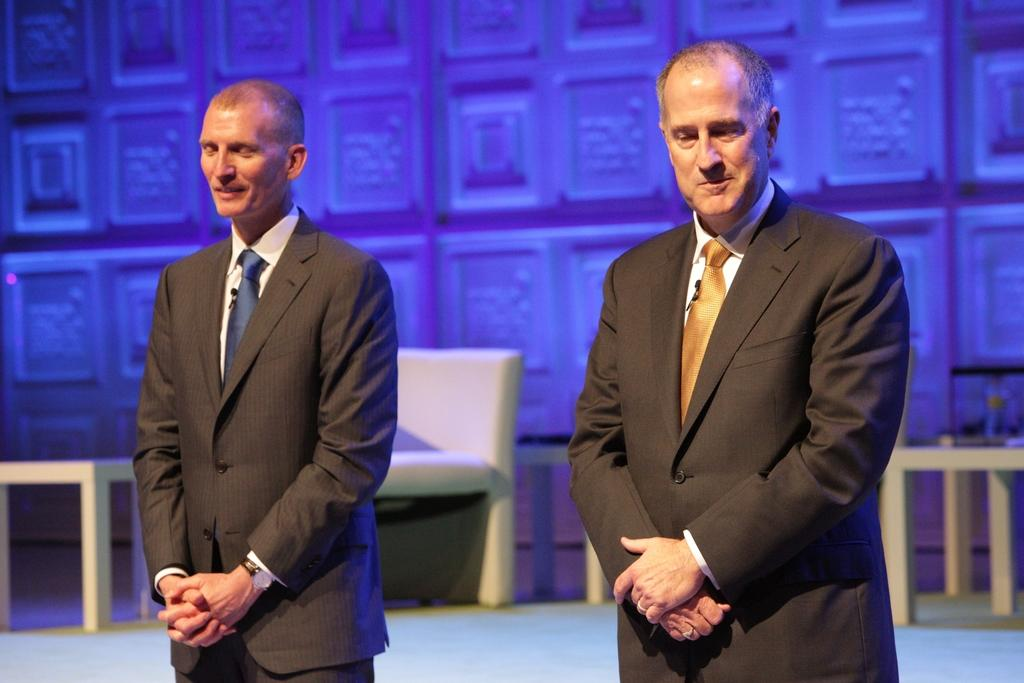What is happening in the image? There are people standing in the image. What can be seen in the background of the image? There are tables and a wall visible in the background of the image. What shape is the smoke coming out of the wall in the image? There is no smoke coming out of the wall in the image. 